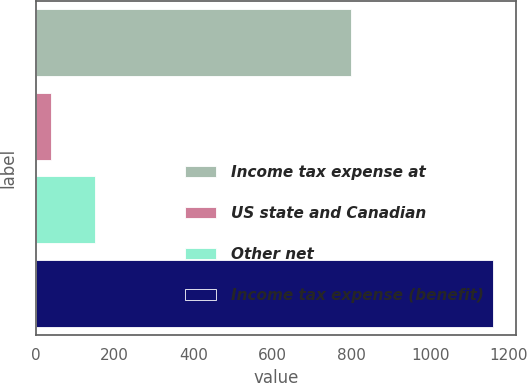Convert chart. <chart><loc_0><loc_0><loc_500><loc_500><bar_chart><fcel>Income tax expense at<fcel>US state and Canadian<fcel>Other net<fcel>Income tax expense (benefit)<nl><fcel>799<fcel>37<fcel>149.3<fcel>1160<nl></chart> 